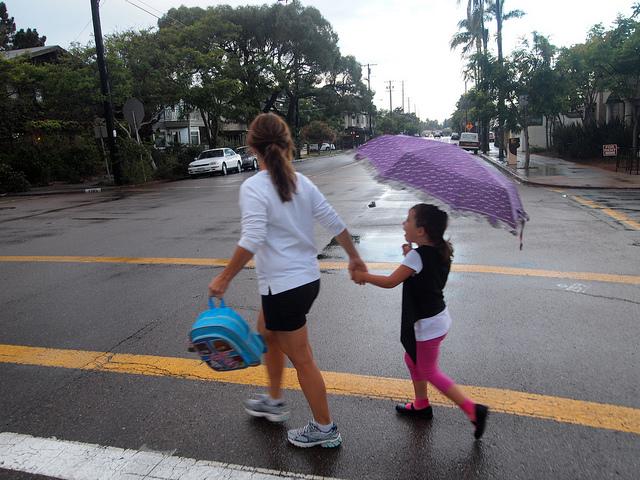How many children are in the walkway?
Keep it brief. 1. What color is the umbrella the little girl on the right wearing?
Keep it brief. Purple. Is the girl wearing high heels?
Quick response, please. No. How many colors are on the umbrella?
Be succinct. 2. 